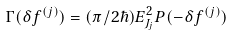Convert formula to latex. <formula><loc_0><loc_0><loc_500><loc_500>\Gamma ( \delta f ^ { ( j ) } ) = ( \pi / 2 \hbar { ) } E _ { J _ { j } } ^ { 2 } P ( - \delta f ^ { ( j ) } )</formula> 